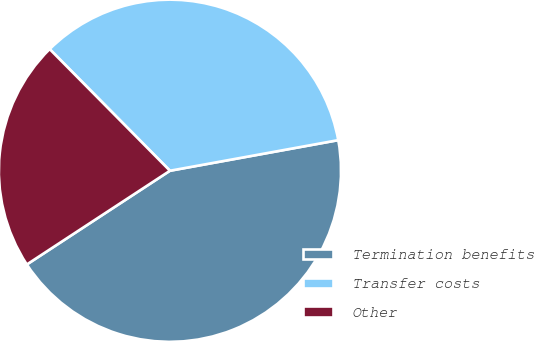Convert chart to OTSL. <chart><loc_0><loc_0><loc_500><loc_500><pie_chart><fcel>Termination benefits<fcel>Transfer costs<fcel>Other<nl><fcel>43.64%<fcel>34.55%<fcel>21.82%<nl></chart> 